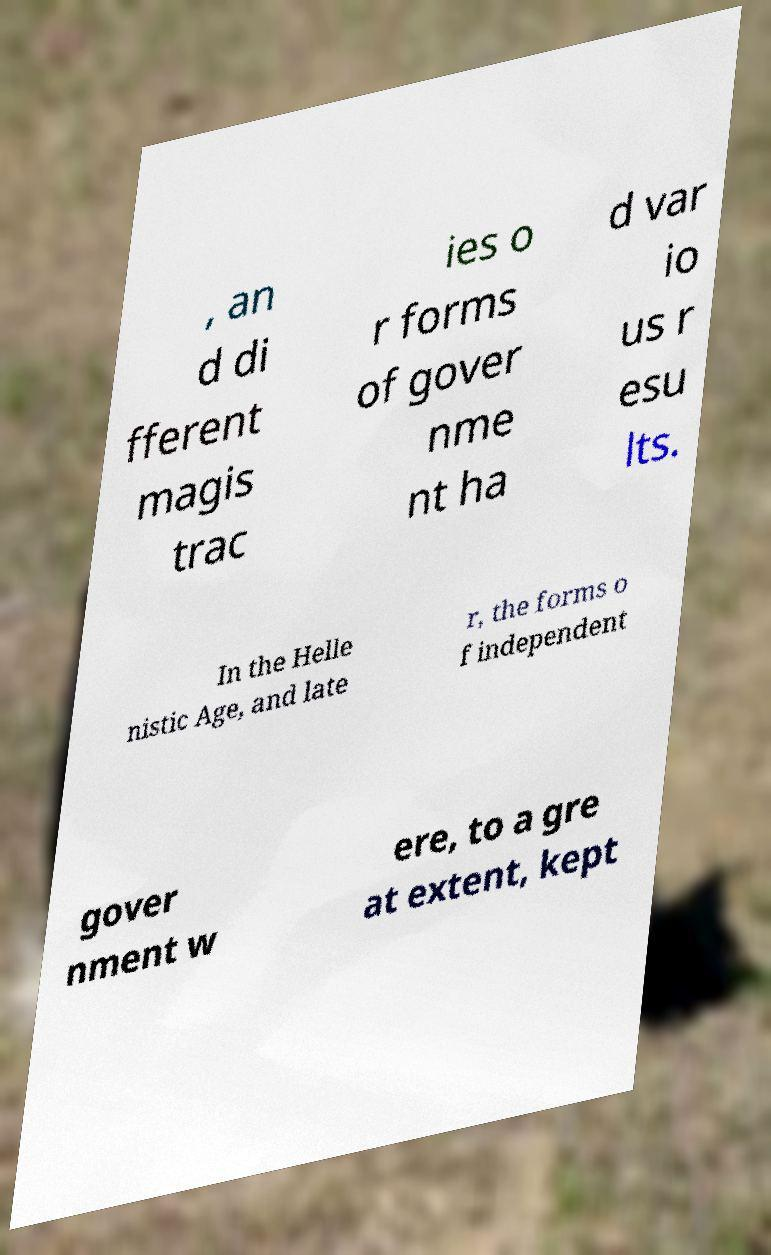Can you read and provide the text displayed in the image?This photo seems to have some interesting text. Can you extract and type it out for me? , an d di fferent magis trac ies o r forms of gover nme nt ha d var io us r esu lts. In the Helle nistic Age, and late r, the forms o f independent gover nment w ere, to a gre at extent, kept 